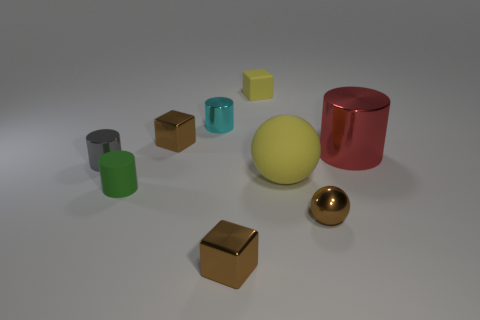Add 1 yellow objects. How many objects exist? 10 Subtract all spheres. How many objects are left? 7 Subtract 0 blue cylinders. How many objects are left? 9 Subtract all cyan metallic cylinders. Subtract all tiny brown shiny spheres. How many objects are left? 7 Add 1 shiny blocks. How many shiny blocks are left? 3 Add 8 cyan rubber balls. How many cyan rubber balls exist? 8 